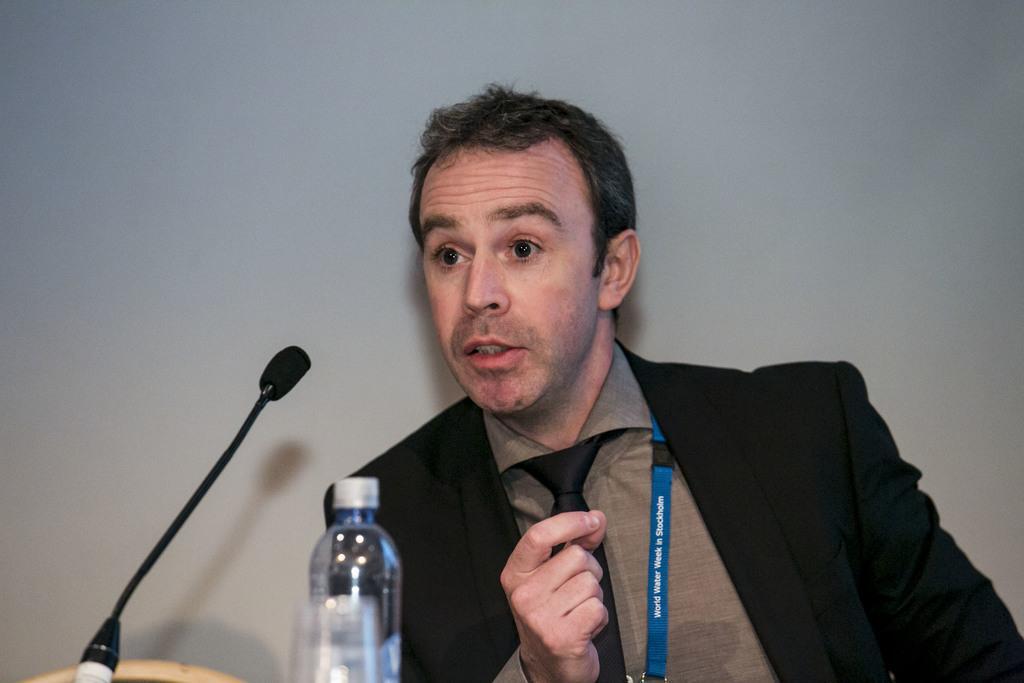Please provide a concise description of this image. In the image there is man wearing a black color suit sitting in front of a microphone and opened his mouth for talking and we can also see a water bottle in the image. In background there is a white color wall. 